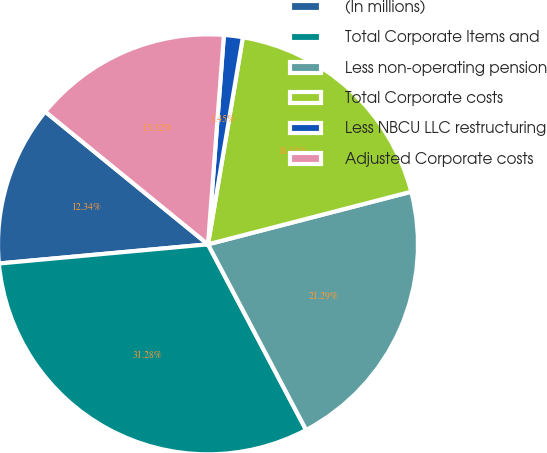<chart> <loc_0><loc_0><loc_500><loc_500><pie_chart><fcel>(In millions)<fcel>Total Corporate Items and<fcel>Less non-operating pension<fcel>Total Corporate costs<fcel>Less NBCU LLC restructuring<fcel>Adjusted Corporate costs<nl><fcel>12.34%<fcel>31.28%<fcel>21.29%<fcel>18.31%<fcel>1.45%<fcel>15.32%<nl></chart> 